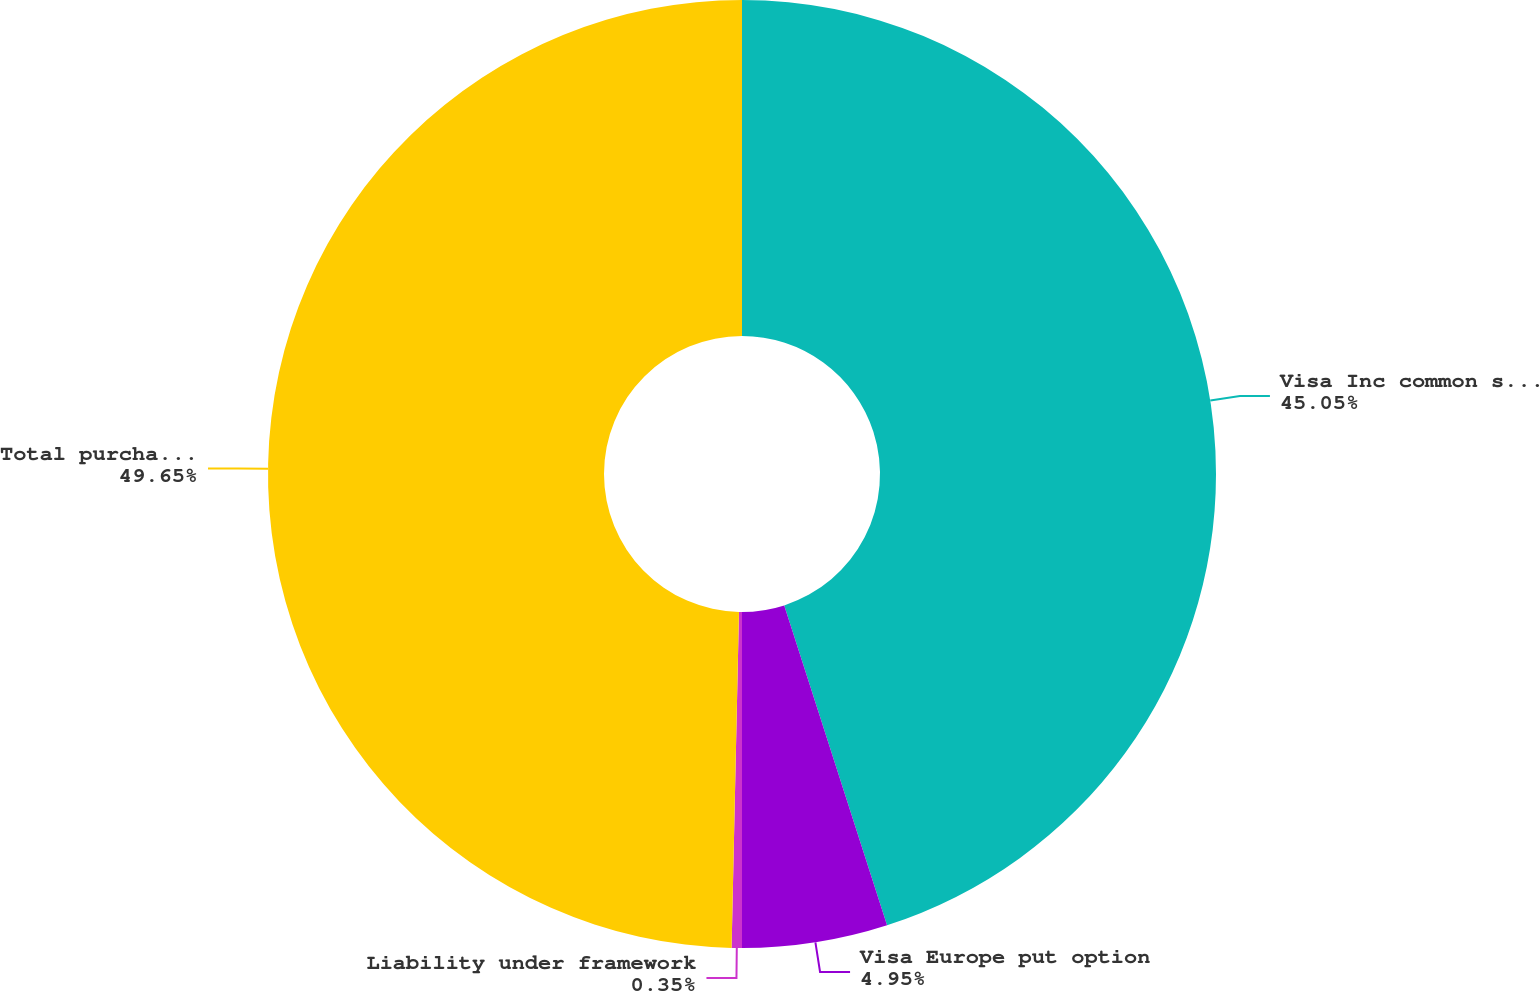Convert chart. <chart><loc_0><loc_0><loc_500><loc_500><pie_chart><fcel>Visa Inc common stock<fcel>Visa Europe put option<fcel>Liability under framework<fcel>Total purchase consideration<nl><fcel>45.05%<fcel>4.95%<fcel>0.35%<fcel>49.65%<nl></chart> 